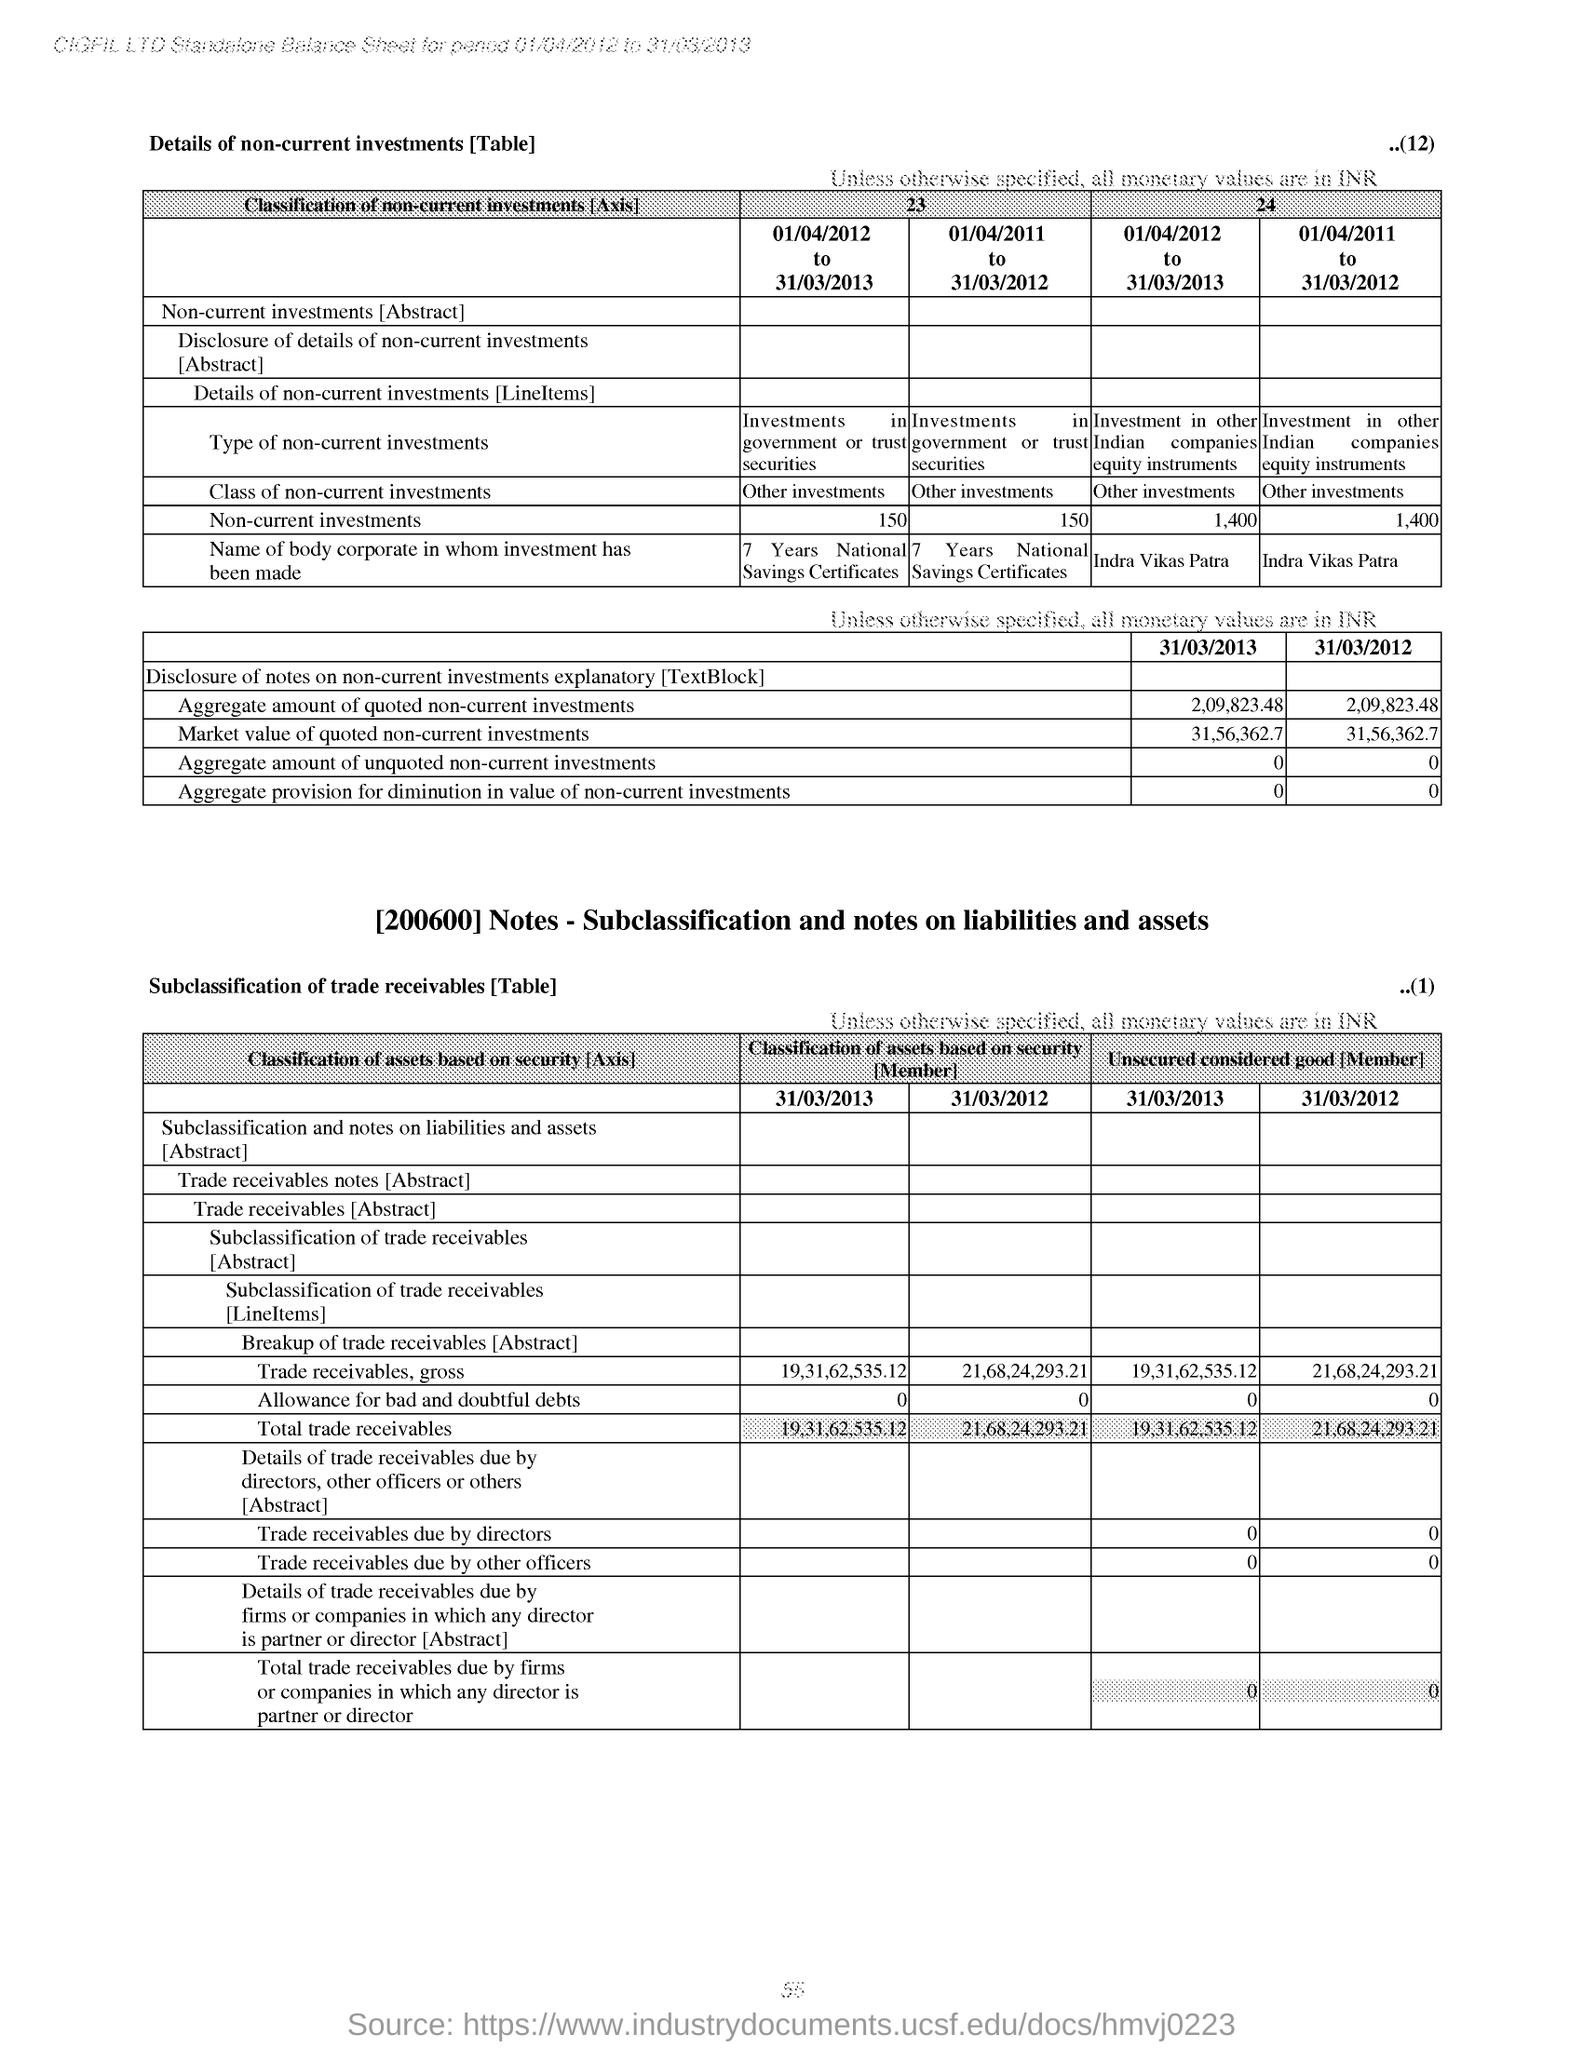What is the 'Market value of quoted non-current investments' for the date '31/03/2013' based on second table
Give a very brief answer. 31,56,362.7. What is Non-current investments for the period 01/04/2011 to 31/03/2012 in column '24' of first table?
Keep it short and to the point. 1,400. 